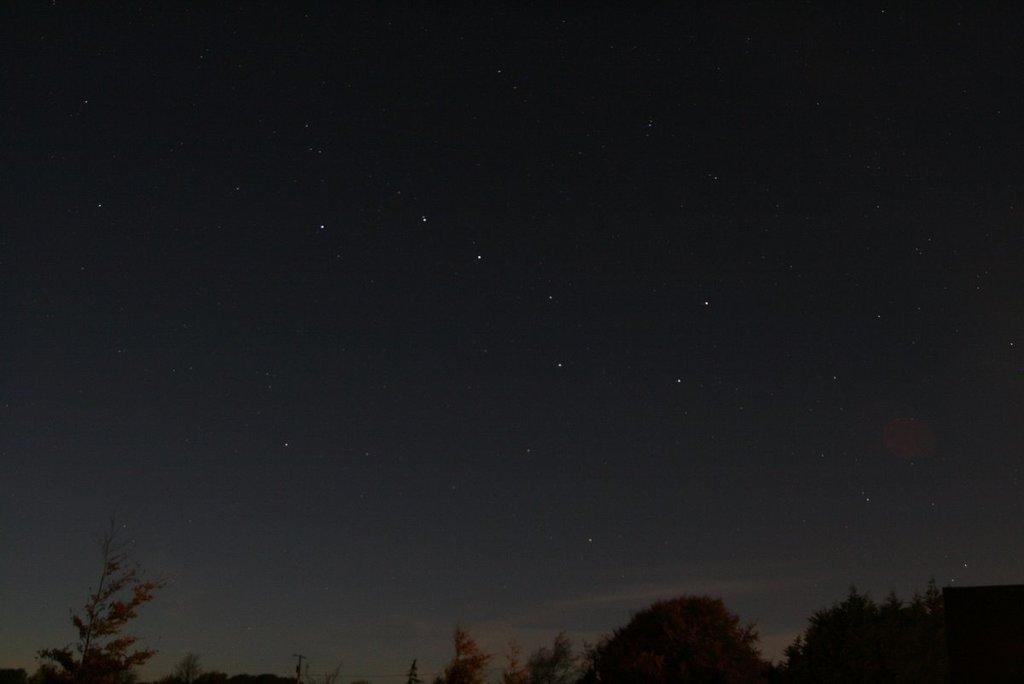What is the primary feature of the image? The primary feature of the image is the presence of many trees. What can be seen in the sky in the image? Stars are visible in the sky in the image. What is the average income of the trees in the image? Trees do not have an income, as they are living organisms and not capable of earning money. 